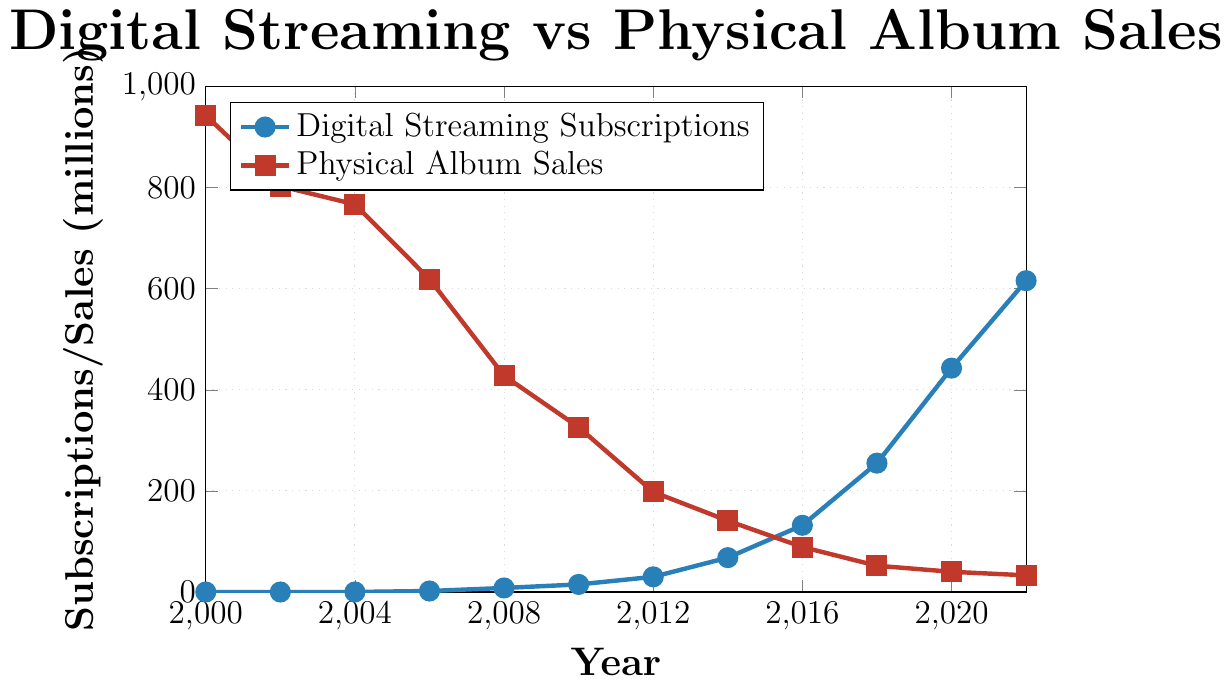What year did digital streaming subscriptions exceed 100 million? The plot shows the trend of digital streaming subscriptions with specific data points marked. Observing the increase, digital streaming subscriptions surpassed 100 million at the point labeled 2016.
Answer: 2016 What is the difference in physical album sales between 2000 and 2022? At the year 2000, physical album sales were 943 million, and by 2022, they were 33 million. The difference is calculated by subtracting the sales in 2022 from those in 2000: 943 - 33 = 910 million.
Answer: 910 million During which year did both digital streaming subscriptions and physical album sales reach 30 million? Observing the values for digital streaming subscriptions and physical album sales, only in 2012 we see both metrics crossing 30 million: digital streaming subscriptions were exactly 30 million, while physical album sales were significantly higher in 2012 but not 30 million for both simultaneously at any year. Therefore, such a point didn't appear.
Answer: Never Compare the rate of change in digital streaming subscriptions between 2010 and 2016 with the rate of change in physical album sales between 2000 and 2006. From 2010 to 2016, digital streaming subscriptions increased from 15 million to 132 million, adding 117 million over six years. Therefore, the rate is 117/6 = 19.5 million per year. For physical album sales, from 2000 to 2006, sales decreased from 943 million to 619 million, dropping 324 million over six years. The rate is 324/6 = 54 million per year.
Answer: Digital: 19.5 million/year, Physical: 54 million/year How many years did it take for digital streaming subscriptions to grow from 8 million to over 250 million? Digital streaming subscriptions were 8 million in 2008 and reached 255 million by 2018, indicating a time span of 10 years.
Answer: 10 years In which year did digital streaming subscriptions surpass physical album sales? Observing the plotted data trends, digital streaming subscriptions surpassed physical album sales by 2016, where the subscriptions were significantly higher, with 132 million compared to 89 million physical album sales.
Answer: 2016 What is the average value of physical album sales from 2000 to 2022? Adding the physical album sales across the years: 943 + 803 + 767 + 619 + 428 + 326 + 198 + 141 + 89 + 52 + 40 + 33 = 4441 million. There are 12 data points, so the average is 4441/12 ≈ 370.08 million.
Answer: 370.08 million Did physical album sales continuously decrease each recorded year from 2000 to 2022? Checking the sequential data points for physical album sales from 2000 to 2022, we can see continuous decline without any year showing a reversal.
Answer: Yes What is the visual difference in color used to represent digital streaming subscriptions and physical album sales? In the chart, digital streaming subscriptions are represented in blue, while physical album sales are depicted in red.
Answer: Blue and red 